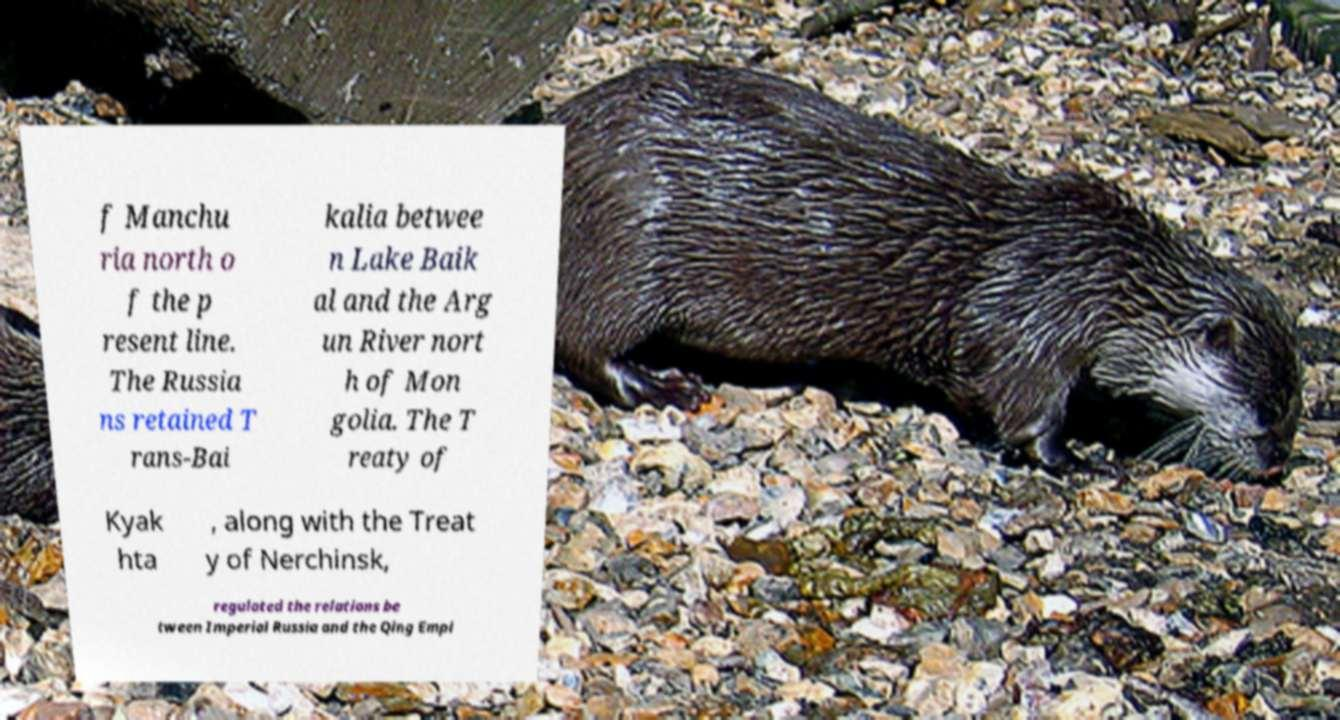For documentation purposes, I need the text within this image transcribed. Could you provide that? f Manchu ria north o f the p resent line. The Russia ns retained T rans-Bai kalia betwee n Lake Baik al and the Arg un River nort h of Mon golia. The T reaty of Kyak hta , along with the Treat y of Nerchinsk, regulated the relations be tween Imperial Russia and the Qing Empi 